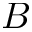Convert formula to latex. <formula><loc_0><loc_0><loc_500><loc_500>B</formula> 